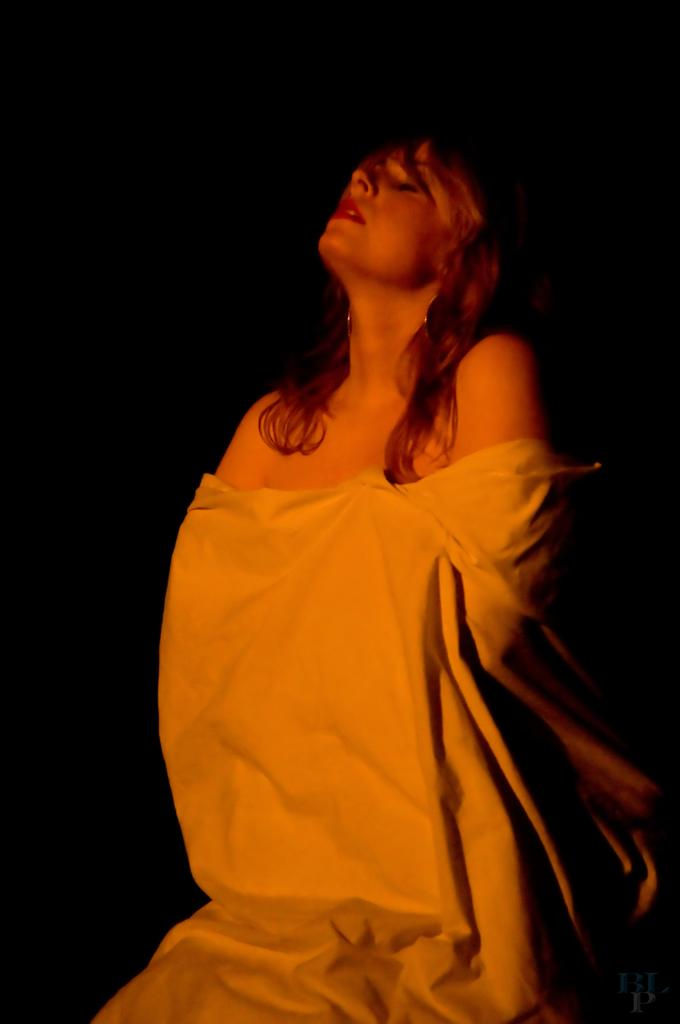Who is the main subject in the image? There is a woman in the image. What is the woman wearing? The woman is wearing a white cloth. What is the color of the background in the image? The background of the image is black. How many cats can be seen attempting to climb the bottle in the image? There are no cats or bottles present in the image. 